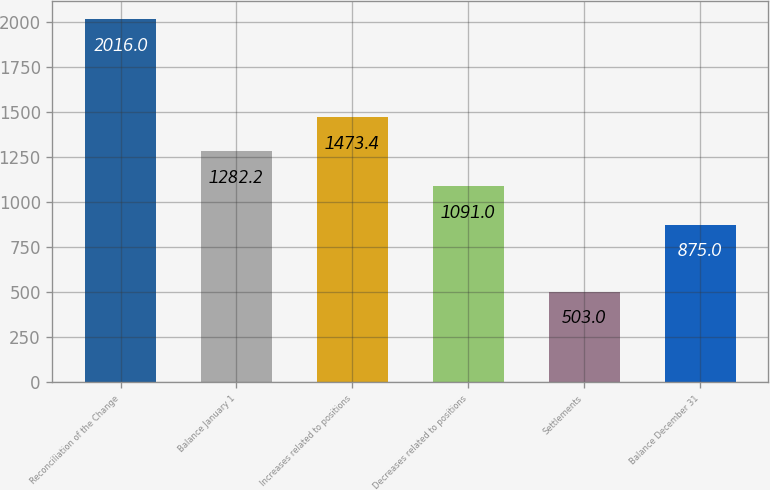Convert chart to OTSL. <chart><loc_0><loc_0><loc_500><loc_500><bar_chart><fcel>Reconciliation of the Change<fcel>Balance January 1<fcel>Increases related to positions<fcel>Decreases related to positions<fcel>Settlements<fcel>Balance December 31<nl><fcel>2016<fcel>1282.2<fcel>1473.4<fcel>1091<fcel>503<fcel>875<nl></chart> 